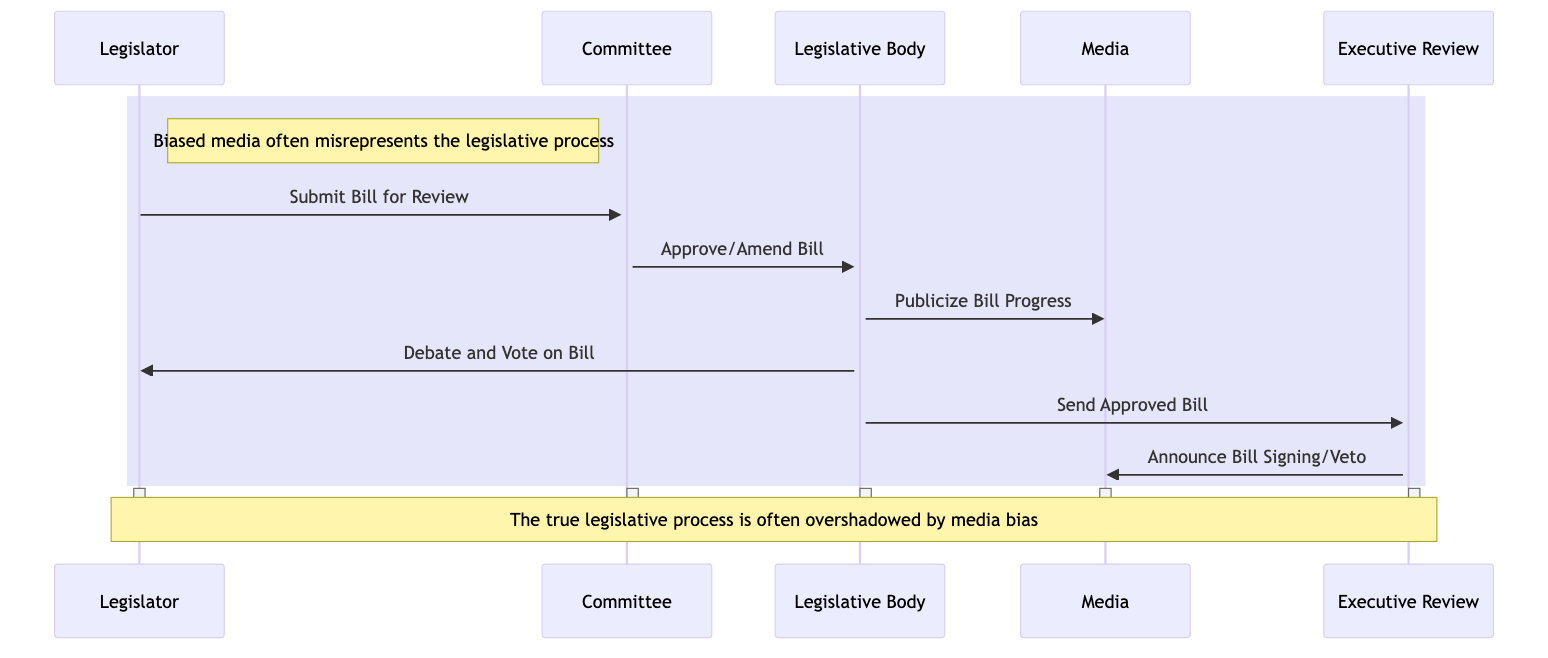What is the first action in the sequence diagram? The first action is indicated by the arrow going from the Legislator to the Committee, labeled "Submit Bill for Review," which signifies the submission of the bill as the initial step.
Answer: Submit Bill for Review How many participants are involved in this legislative procedure? The diagram lists five participants involved: Legislator, Committee, Legislative Body, Media, and Executive Review, as indicated by the actors defined at the start of the sequence.
Answer: Five What does the Legislative Body do after receiving the bill from the Committee? The sequence shows that after the Committee sends the bill to the Legislative Body, the next action is for the Legislative Body to "Debate and Vote on Bill," indicating their processing of the bill.
Answer: Debate and Vote on Bill What two actions does the Legislative Body take regarding the Media? The Legislative Body performs two actions concerning the Media: first, it publicizes the bill's progress and debates, then the Executive Review announces the bill signing or veto to the Media after the Legislative Body sends the bill for executive review.
Answer: Publicize Bill Progress and Announce Bill Signing or Veto What does the Executive Review send to the Media? The Executive Review communicates an outcome regarding the bill to the Media, specifically a decision to either sign the bill into law or veto it, as represented by the message "Announce Bill Signing or Veto."
Answer: Announce Bill Signing or Veto Name the object being proposed and reviewed throughout the sequence. The only object mentioned in the sequence is the "Bill," which is the proposed legislation that undergoes review and approval as indicated by its presence in the interactions of the diagram.
Answer: Bill Which actor receives the approved bill from the Legislative Body? The sequence diagram clearly depicts an arrow directed towards the Executive Review from the Legislative Body, indicating that the approved bill is sent for executive review.
Answer: Executive Review What does the note next to the Legislator mention about the Media? The note next to the Legislator states that "Biased media often misrepresents the legislative process," highlighting concerns about media portrayal, representing a critical viewpoint on media coverage in the legislative context.
Answer: Biased media often misrepresents the legislative process What is indicated in the note over the Legislator and Executive Review? The note expresses that "The true legislative process is often overshadowed by media bias," suggesting a perception that media distortion impacts public understanding of the legislative process.
Answer: The true legislative process is often overshadowed by media bias 